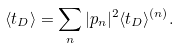Convert formula to latex. <formula><loc_0><loc_0><loc_500><loc_500>\langle t _ { D } \rangle = \sum _ { n } | p _ { n } | ^ { 2 } \langle t _ { D } \rangle ^ { ( n ) } .</formula> 